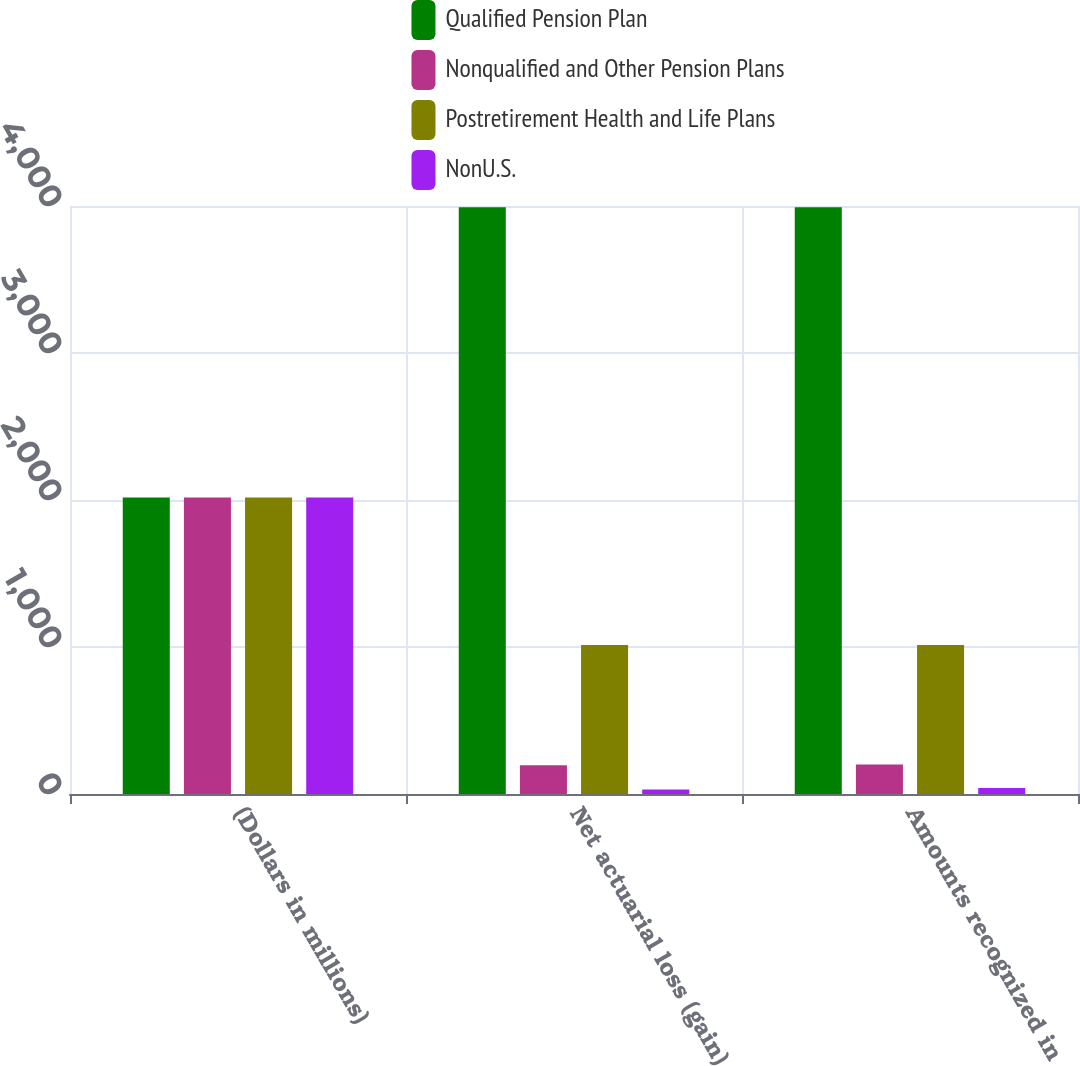Convert chart. <chart><loc_0><loc_0><loc_500><loc_500><stacked_bar_chart><ecel><fcel>(Dollars in millions)<fcel>Net actuarial loss (gain)<fcel>Amounts recognized in<nl><fcel>Qualified Pension Plan<fcel>2017<fcel>3992<fcel>3992<nl><fcel>Nonqualified and Other Pension Plans<fcel>2017<fcel>196<fcel>200<nl><fcel>Postretirement Health and Life Plans<fcel>2017<fcel>1014<fcel>1014<nl><fcel>NonU.S.<fcel>2017<fcel>30<fcel>41<nl></chart> 